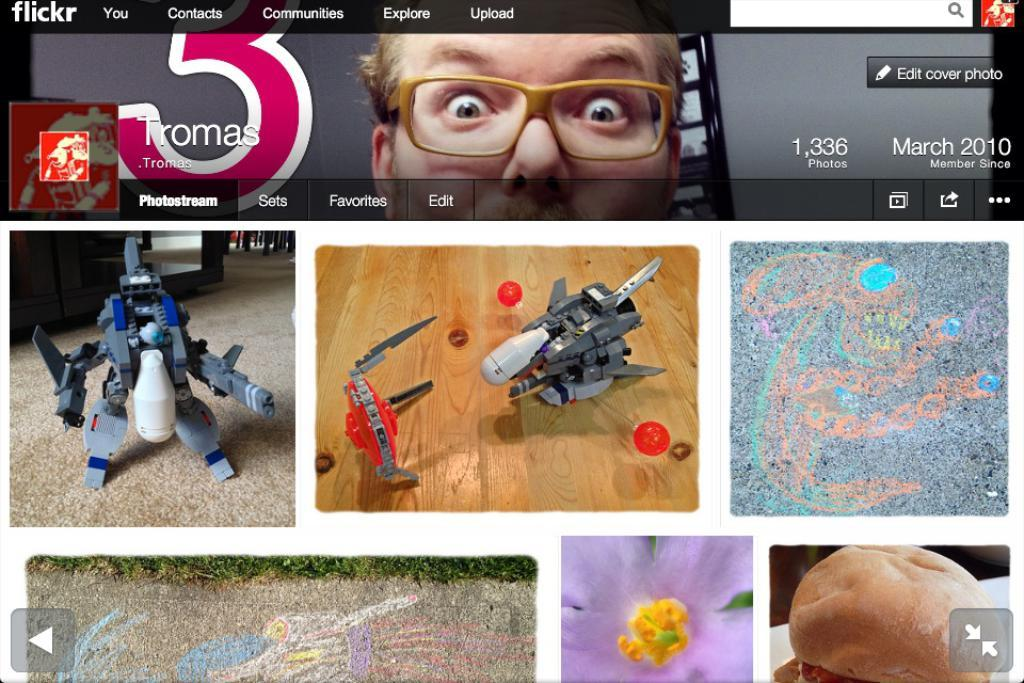What type of images can be found on the Flickr page? There are images of robots, food items, and other images on the Flickr page. Can you describe one of the images of robots? Unfortunately, the specific details of the images are not provided, but we know that there are images of robots on the Flickr page. What other types of images are present on the Flickr page? There are images of food items on the Flickr page, in addition to the images of robots and other images. Is there a person's face visible on the Flickr page? Yes, there is a person's face with glasses on the Flickr page. What type of harmony is being played by the writer in the image? There is no writer or harmony present in the image; it features images of robots, food items, and other images, as well as a person's face with glasses. 